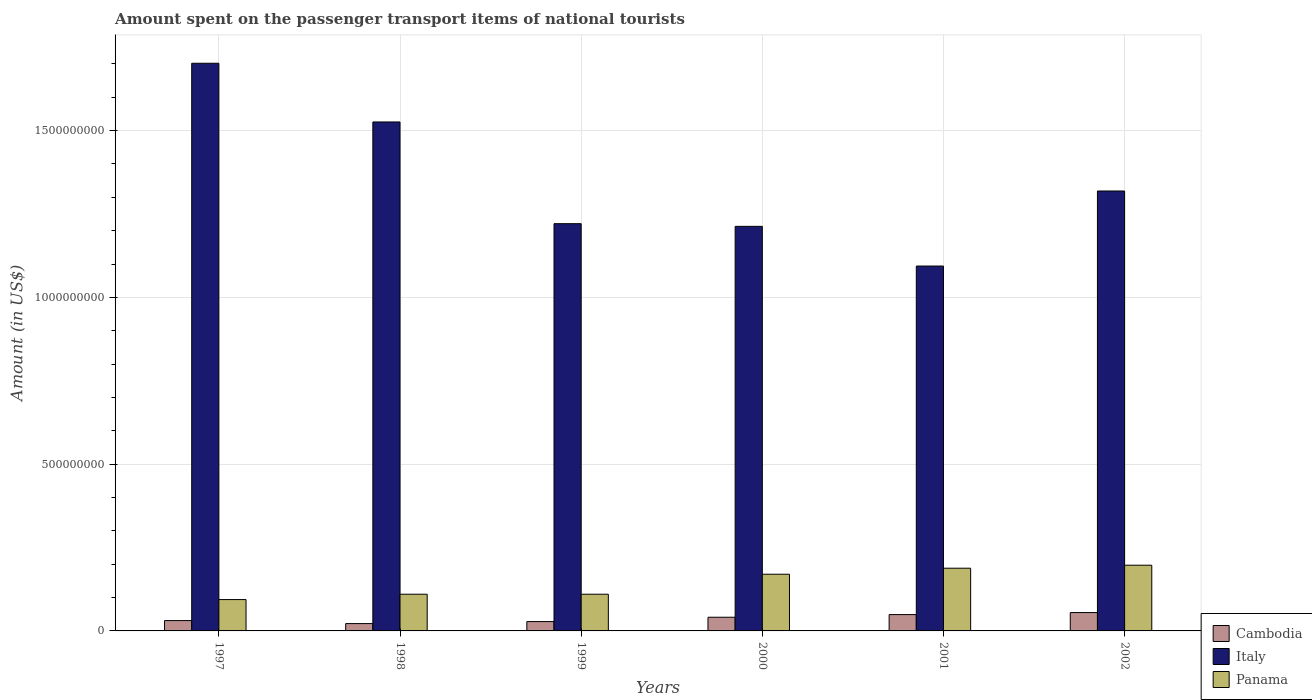How many different coloured bars are there?
Your response must be concise. 3. Are the number of bars on each tick of the X-axis equal?
Your answer should be very brief. Yes. How many bars are there on the 1st tick from the left?
Make the answer very short. 3. In how many cases, is the number of bars for a given year not equal to the number of legend labels?
Your answer should be very brief. 0. What is the amount spent on the passenger transport items of national tourists in Italy in 2002?
Keep it short and to the point. 1.32e+09. Across all years, what is the maximum amount spent on the passenger transport items of national tourists in Cambodia?
Offer a terse response. 5.50e+07. Across all years, what is the minimum amount spent on the passenger transport items of national tourists in Italy?
Make the answer very short. 1.09e+09. In which year was the amount spent on the passenger transport items of national tourists in Cambodia maximum?
Provide a short and direct response. 2002. What is the total amount spent on the passenger transport items of national tourists in Cambodia in the graph?
Ensure brevity in your answer.  2.26e+08. What is the difference between the amount spent on the passenger transport items of national tourists in Panama in 1997 and that in 2002?
Your answer should be compact. -1.03e+08. What is the difference between the amount spent on the passenger transport items of national tourists in Italy in 2002 and the amount spent on the passenger transport items of national tourists in Cambodia in 1999?
Make the answer very short. 1.29e+09. What is the average amount spent on the passenger transport items of national tourists in Cambodia per year?
Ensure brevity in your answer.  3.77e+07. In the year 1997, what is the difference between the amount spent on the passenger transport items of national tourists in Cambodia and amount spent on the passenger transport items of national tourists in Italy?
Keep it short and to the point. -1.67e+09. In how many years, is the amount spent on the passenger transport items of national tourists in Italy greater than 1300000000 US$?
Make the answer very short. 3. What is the ratio of the amount spent on the passenger transport items of national tourists in Cambodia in 1997 to that in 1999?
Your answer should be compact. 1.11. Is the amount spent on the passenger transport items of national tourists in Italy in 1997 less than that in 1998?
Your answer should be very brief. No. Is the difference between the amount spent on the passenger transport items of national tourists in Cambodia in 2000 and 2001 greater than the difference between the amount spent on the passenger transport items of national tourists in Italy in 2000 and 2001?
Make the answer very short. No. What is the difference between the highest and the second highest amount spent on the passenger transport items of national tourists in Cambodia?
Your response must be concise. 6.00e+06. What is the difference between the highest and the lowest amount spent on the passenger transport items of national tourists in Cambodia?
Provide a short and direct response. 3.30e+07. In how many years, is the amount spent on the passenger transport items of national tourists in Panama greater than the average amount spent on the passenger transport items of national tourists in Panama taken over all years?
Your answer should be compact. 3. Is the sum of the amount spent on the passenger transport items of national tourists in Panama in 1999 and 2000 greater than the maximum amount spent on the passenger transport items of national tourists in Cambodia across all years?
Provide a short and direct response. Yes. What does the 1st bar from the right in 2001 represents?
Your response must be concise. Panama. Is it the case that in every year, the sum of the amount spent on the passenger transport items of national tourists in Panama and amount spent on the passenger transport items of national tourists in Italy is greater than the amount spent on the passenger transport items of national tourists in Cambodia?
Ensure brevity in your answer.  Yes. How many bars are there?
Your response must be concise. 18. Are all the bars in the graph horizontal?
Offer a terse response. No. What is the difference between two consecutive major ticks on the Y-axis?
Your response must be concise. 5.00e+08. Where does the legend appear in the graph?
Your answer should be compact. Bottom right. What is the title of the graph?
Your answer should be very brief. Amount spent on the passenger transport items of national tourists. What is the Amount (in US$) in Cambodia in 1997?
Keep it short and to the point. 3.10e+07. What is the Amount (in US$) in Italy in 1997?
Keep it short and to the point. 1.70e+09. What is the Amount (in US$) in Panama in 1997?
Your answer should be compact. 9.40e+07. What is the Amount (in US$) of Cambodia in 1998?
Provide a short and direct response. 2.20e+07. What is the Amount (in US$) in Italy in 1998?
Make the answer very short. 1.53e+09. What is the Amount (in US$) of Panama in 1998?
Provide a succinct answer. 1.10e+08. What is the Amount (in US$) of Cambodia in 1999?
Offer a very short reply. 2.80e+07. What is the Amount (in US$) in Italy in 1999?
Offer a terse response. 1.22e+09. What is the Amount (in US$) of Panama in 1999?
Your answer should be very brief. 1.10e+08. What is the Amount (in US$) of Cambodia in 2000?
Provide a short and direct response. 4.10e+07. What is the Amount (in US$) in Italy in 2000?
Provide a succinct answer. 1.21e+09. What is the Amount (in US$) of Panama in 2000?
Provide a succinct answer. 1.70e+08. What is the Amount (in US$) of Cambodia in 2001?
Offer a terse response. 4.90e+07. What is the Amount (in US$) in Italy in 2001?
Provide a short and direct response. 1.09e+09. What is the Amount (in US$) in Panama in 2001?
Offer a very short reply. 1.88e+08. What is the Amount (in US$) of Cambodia in 2002?
Ensure brevity in your answer.  5.50e+07. What is the Amount (in US$) in Italy in 2002?
Offer a terse response. 1.32e+09. What is the Amount (in US$) in Panama in 2002?
Offer a very short reply. 1.97e+08. Across all years, what is the maximum Amount (in US$) in Cambodia?
Your answer should be compact. 5.50e+07. Across all years, what is the maximum Amount (in US$) in Italy?
Offer a terse response. 1.70e+09. Across all years, what is the maximum Amount (in US$) of Panama?
Your answer should be very brief. 1.97e+08. Across all years, what is the minimum Amount (in US$) of Cambodia?
Ensure brevity in your answer.  2.20e+07. Across all years, what is the minimum Amount (in US$) of Italy?
Ensure brevity in your answer.  1.09e+09. Across all years, what is the minimum Amount (in US$) of Panama?
Give a very brief answer. 9.40e+07. What is the total Amount (in US$) in Cambodia in the graph?
Give a very brief answer. 2.26e+08. What is the total Amount (in US$) of Italy in the graph?
Provide a short and direct response. 8.08e+09. What is the total Amount (in US$) of Panama in the graph?
Provide a short and direct response. 8.69e+08. What is the difference between the Amount (in US$) of Cambodia in 1997 and that in 1998?
Your answer should be very brief. 9.00e+06. What is the difference between the Amount (in US$) of Italy in 1997 and that in 1998?
Your response must be concise. 1.76e+08. What is the difference between the Amount (in US$) in Panama in 1997 and that in 1998?
Provide a succinct answer. -1.60e+07. What is the difference between the Amount (in US$) in Cambodia in 1997 and that in 1999?
Make the answer very short. 3.00e+06. What is the difference between the Amount (in US$) in Italy in 1997 and that in 1999?
Your answer should be very brief. 4.81e+08. What is the difference between the Amount (in US$) of Panama in 1997 and that in 1999?
Your answer should be compact. -1.60e+07. What is the difference between the Amount (in US$) in Cambodia in 1997 and that in 2000?
Ensure brevity in your answer.  -1.00e+07. What is the difference between the Amount (in US$) of Italy in 1997 and that in 2000?
Offer a terse response. 4.89e+08. What is the difference between the Amount (in US$) of Panama in 1997 and that in 2000?
Ensure brevity in your answer.  -7.60e+07. What is the difference between the Amount (in US$) of Cambodia in 1997 and that in 2001?
Your answer should be compact. -1.80e+07. What is the difference between the Amount (in US$) of Italy in 1997 and that in 2001?
Give a very brief answer. 6.08e+08. What is the difference between the Amount (in US$) of Panama in 1997 and that in 2001?
Your answer should be very brief. -9.40e+07. What is the difference between the Amount (in US$) of Cambodia in 1997 and that in 2002?
Ensure brevity in your answer.  -2.40e+07. What is the difference between the Amount (in US$) in Italy in 1997 and that in 2002?
Your response must be concise. 3.83e+08. What is the difference between the Amount (in US$) of Panama in 1997 and that in 2002?
Your answer should be very brief. -1.03e+08. What is the difference between the Amount (in US$) of Cambodia in 1998 and that in 1999?
Ensure brevity in your answer.  -6.00e+06. What is the difference between the Amount (in US$) of Italy in 1998 and that in 1999?
Your response must be concise. 3.05e+08. What is the difference between the Amount (in US$) of Cambodia in 1998 and that in 2000?
Provide a succinct answer. -1.90e+07. What is the difference between the Amount (in US$) in Italy in 1998 and that in 2000?
Your answer should be very brief. 3.13e+08. What is the difference between the Amount (in US$) of Panama in 1998 and that in 2000?
Provide a succinct answer. -6.00e+07. What is the difference between the Amount (in US$) of Cambodia in 1998 and that in 2001?
Your answer should be very brief. -2.70e+07. What is the difference between the Amount (in US$) in Italy in 1998 and that in 2001?
Ensure brevity in your answer.  4.32e+08. What is the difference between the Amount (in US$) in Panama in 1998 and that in 2001?
Your response must be concise. -7.80e+07. What is the difference between the Amount (in US$) in Cambodia in 1998 and that in 2002?
Keep it short and to the point. -3.30e+07. What is the difference between the Amount (in US$) in Italy in 1998 and that in 2002?
Your response must be concise. 2.07e+08. What is the difference between the Amount (in US$) in Panama in 1998 and that in 2002?
Your answer should be compact. -8.70e+07. What is the difference between the Amount (in US$) in Cambodia in 1999 and that in 2000?
Ensure brevity in your answer.  -1.30e+07. What is the difference between the Amount (in US$) of Italy in 1999 and that in 2000?
Provide a succinct answer. 8.00e+06. What is the difference between the Amount (in US$) in Panama in 1999 and that in 2000?
Your answer should be compact. -6.00e+07. What is the difference between the Amount (in US$) in Cambodia in 1999 and that in 2001?
Provide a short and direct response. -2.10e+07. What is the difference between the Amount (in US$) of Italy in 1999 and that in 2001?
Your response must be concise. 1.27e+08. What is the difference between the Amount (in US$) of Panama in 1999 and that in 2001?
Offer a terse response. -7.80e+07. What is the difference between the Amount (in US$) in Cambodia in 1999 and that in 2002?
Keep it short and to the point. -2.70e+07. What is the difference between the Amount (in US$) of Italy in 1999 and that in 2002?
Offer a terse response. -9.80e+07. What is the difference between the Amount (in US$) of Panama in 1999 and that in 2002?
Your response must be concise. -8.70e+07. What is the difference between the Amount (in US$) in Cambodia in 2000 and that in 2001?
Ensure brevity in your answer.  -8.00e+06. What is the difference between the Amount (in US$) of Italy in 2000 and that in 2001?
Your answer should be compact. 1.19e+08. What is the difference between the Amount (in US$) in Panama in 2000 and that in 2001?
Keep it short and to the point. -1.80e+07. What is the difference between the Amount (in US$) in Cambodia in 2000 and that in 2002?
Offer a very short reply. -1.40e+07. What is the difference between the Amount (in US$) of Italy in 2000 and that in 2002?
Give a very brief answer. -1.06e+08. What is the difference between the Amount (in US$) of Panama in 2000 and that in 2002?
Keep it short and to the point. -2.70e+07. What is the difference between the Amount (in US$) in Cambodia in 2001 and that in 2002?
Keep it short and to the point. -6.00e+06. What is the difference between the Amount (in US$) in Italy in 2001 and that in 2002?
Make the answer very short. -2.25e+08. What is the difference between the Amount (in US$) in Panama in 2001 and that in 2002?
Give a very brief answer. -9.00e+06. What is the difference between the Amount (in US$) of Cambodia in 1997 and the Amount (in US$) of Italy in 1998?
Your answer should be compact. -1.50e+09. What is the difference between the Amount (in US$) of Cambodia in 1997 and the Amount (in US$) of Panama in 1998?
Your answer should be compact. -7.90e+07. What is the difference between the Amount (in US$) in Italy in 1997 and the Amount (in US$) in Panama in 1998?
Keep it short and to the point. 1.59e+09. What is the difference between the Amount (in US$) in Cambodia in 1997 and the Amount (in US$) in Italy in 1999?
Provide a succinct answer. -1.19e+09. What is the difference between the Amount (in US$) in Cambodia in 1997 and the Amount (in US$) in Panama in 1999?
Provide a short and direct response. -7.90e+07. What is the difference between the Amount (in US$) of Italy in 1997 and the Amount (in US$) of Panama in 1999?
Keep it short and to the point. 1.59e+09. What is the difference between the Amount (in US$) of Cambodia in 1997 and the Amount (in US$) of Italy in 2000?
Your answer should be compact. -1.18e+09. What is the difference between the Amount (in US$) in Cambodia in 1997 and the Amount (in US$) in Panama in 2000?
Your answer should be very brief. -1.39e+08. What is the difference between the Amount (in US$) in Italy in 1997 and the Amount (in US$) in Panama in 2000?
Offer a terse response. 1.53e+09. What is the difference between the Amount (in US$) in Cambodia in 1997 and the Amount (in US$) in Italy in 2001?
Keep it short and to the point. -1.06e+09. What is the difference between the Amount (in US$) in Cambodia in 1997 and the Amount (in US$) in Panama in 2001?
Give a very brief answer. -1.57e+08. What is the difference between the Amount (in US$) in Italy in 1997 and the Amount (in US$) in Panama in 2001?
Provide a short and direct response. 1.51e+09. What is the difference between the Amount (in US$) in Cambodia in 1997 and the Amount (in US$) in Italy in 2002?
Provide a short and direct response. -1.29e+09. What is the difference between the Amount (in US$) in Cambodia in 1997 and the Amount (in US$) in Panama in 2002?
Provide a short and direct response. -1.66e+08. What is the difference between the Amount (in US$) of Italy in 1997 and the Amount (in US$) of Panama in 2002?
Offer a terse response. 1.50e+09. What is the difference between the Amount (in US$) in Cambodia in 1998 and the Amount (in US$) in Italy in 1999?
Make the answer very short. -1.20e+09. What is the difference between the Amount (in US$) in Cambodia in 1998 and the Amount (in US$) in Panama in 1999?
Offer a very short reply. -8.80e+07. What is the difference between the Amount (in US$) of Italy in 1998 and the Amount (in US$) of Panama in 1999?
Provide a succinct answer. 1.42e+09. What is the difference between the Amount (in US$) of Cambodia in 1998 and the Amount (in US$) of Italy in 2000?
Provide a succinct answer. -1.19e+09. What is the difference between the Amount (in US$) of Cambodia in 1998 and the Amount (in US$) of Panama in 2000?
Ensure brevity in your answer.  -1.48e+08. What is the difference between the Amount (in US$) in Italy in 1998 and the Amount (in US$) in Panama in 2000?
Your response must be concise. 1.36e+09. What is the difference between the Amount (in US$) in Cambodia in 1998 and the Amount (in US$) in Italy in 2001?
Make the answer very short. -1.07e+09. What is the difference between the Amount (in US$) in Cambodia in 1998 and the Amount (in US$) in Panama in 2001?
Keep it short and to the point. -1.66e+08. What is the difference between the Amount (in US$) of Italy in 1998 and the Amount (in US$) of Panama in 2001?
Keep it short and to the point. 1.34e+09. What is the difference between the Amount (in US$) in Cambodia in 1998 and the Amount (in US$) in Italy in 2002?
Your answer should be compact. -1.30e+09. What is the difference between the Amount (in US$) in Cambodia in 1998 and the Amount (in US$) in Panama in 2002?
Your response must be concise. -1.75e+08. What is the difference between the Amount (in US$) in Italy in 1998 and the Amount (in US$) in Panama in 2002?
Provide a succinct answer. 1.33e+09. What is the difference between the Amount (in US$) in Cambodia in 1999 and the Amount (in US$) in Italy in 2000?
Your response must be concise. -1.18e+09. What is the difference between the Amount (in US$) in Cambodia in 1999 and the Amount (in US$) in Panama in 2000?
Your response must be concise. -1.42e+08. What is the difference between the Amount (in US$) in Italy in 1999 and the Amount (in US$) in Panama in 2000?
Provide a succinct answer. 1.05e+09. What is the difference between the Amount (in US$) in Cambodia in 1999 and the Amount (in US$) in Italy in 2001?
Your answer should be compact. -1.07e+09. What is the difference between the Amount (in US$) of Cambodia in 1999 and the Amount (in US$) of Panama in 2001?
Provide a succinct answer. -1.60e+08. What is the difference between the Amount (in US$) of Italy in 1999 and the Amount (in US$) of Panama in 2001?
Your response must be concise. 1.03e+09. What is the difference between the Amount (in US$) of Cambodia in 1999 and the Amount (in US$) of Italy in 2002?
Provide a short and direct response. -1.29e+09. What is the difference between the Amount (in US$) in Cambodia in 1999 and the Amount (in US$) in Panama in 2002?
Keep it short and to the point. -1.69e+08. What is the difference between the Amount (in US$) in Italy in 1999 and the Amount (in US$) in Panama in 2002?
Offer a terse response. 1.02e+09. What is the difference between the Amount (in US$) in Cambodia in 2000 and the Amount (in US$) in Italy in 2001?
Ensure brevity in your answer.  -1.05e+09. What is the difference between the Amount (in US$) of Cambodia in 2000 and the Amount (in US$) of Panama in 2001?
Make the answer very short. -1.47e+08. What is the difference between the Amount (in US$) of Italy in 2000 and the Amount (in US$) of Panama in 2001?
Provide a short and direct response. 1.02e+09. What is the difference between the Amount (in US$) of Cambodia in 2000 and the Amount (in US$) of Italy in 2002?
Keep it short and to the point. -1.28e+09. What is the difference between the Amount (in US$) in Cambodia in 2000 and the Amount (in US$) in Panama in 2002?
Give a very brief answer. -1.56e+08. What is the difference between the Amount (in US$) in Italy in 2000 and the Amount (in US$) in Panama in 2002?
Keep it short and to the point. 1.02e+09. What is the difference between the Amount (in US$) in Cambodia in 2001 and the Amount (in US$) in Italy in 2002?
Make the answer very short. -1.27e+09. What is the difference between the Amount (in US$) in Cambodia in 2001 and the Amount (in US$) in Panama in 2002?
Your answer should be compact. -1.48e+08. What is the difference between the Amount (in US$) of Italy in 2001 and the Amount (in US$) of Panama in 2002?
Your response must be concise. 8.97e+08. What is the average Amount (in US$) in Cambodia per year?
Your answer should be very brief. 3.77e+07. What is the average Amount (in US$) of Italy per year?
Your answer should be very brief. 1.35e+09. What is the average Amount (in US$) in Panama per year?
Offer a terse response. 1.45e+08. In the year 1997, what is the difference between the Amount (in US$) in Cambodia and Amount (in US$) in Italy?
Offer a terse response. -1.67e+09. In the year 1997, what is the difference between the Amount (in US$) of Cambodia and Amount (in US$) of Panama?
Make the answer very short. -6.30e+07. In the year 1997, what is the difference between the Amount (in US$) in Italy and Amount (in US$) in Panama?
Provide a succinct answer. 1.61e+09. In the year 1998, what is the difference between the Amount (in US$) in Cambodia and Amount (in US$) in Italy?
Provide a short and direct response. -1.50e+09. In the year 1998, what is the difference between the Amount (in US$) in Cambodia and Amount (in US$) in Panama?
Offer a terse response. -8.80e+07. In the year 1998, what is the difference between the Amount (in US$) of Italy and Amount (in US$) of Panama?
Offer a very short reply. 1.42e+09. In the year 1999, what is the difference between the Amount (in US$) of Cambodia and Amount (in US$) of Italy?
Provide a short and direct response. -1.19e+09. In the year 1999, what is the difference between the Amount (in US$) in Cambodia and Amount (in US$) in Panama?
Keep it short and to the point. -8.20e+07. In the year 1999, what is the difference between the Amount (in US$) of Italy and Amount (in US$) of Panama?
Offer a very short reply. 1.11e+09. In the year 2000, what is the difference between the Amount (in US$) in Cambodia and Amount (in US$) in Italy?
Ensure brevity in your answer.  -1.17e+09. In the year 2000, what is the difference between the Amount (in US$) in Cambodia and Amount (in US$) in Panama?
Offer a terse response. -1.29e+08. In the year 2000, what is the difference between the Amount (in US$) in Italy and Amount (in US$) in Panama?
Ensure brevity in your answer.  1.04e+09. In the year 2001, what is the difference between the Amount (in US$) of Cambodia and Amount (in US$) of Italy?
Your answer should be very brief. -1.04e+09. In the year 2001, what is the difference between the Amount (in US$) in Cambodia and Amount (in US$) in Panama?
Keep it short and to the point. -1.39e+08. In the year 2001, what is the difference between the Amount (in US$) of Italy and Amount (in US$) of Panama?
Offer a terse response. 9.06e+08. In the year 2002, what is the difference between the Amount (in US$) in Cambodia and Amount (in US$) in Italy?
Your response must be concise. -1.26e+09. In the year 2002, what is the difference between the Amount (in US$) in Cambodia and Amount (in US$) in Panama?
Your answer should be very brief. -1.42e+08. In the year 2002, what is the difference between the Amount (in US$) of Italy and Amount (in US$) of Panama?
Provide a short and direct response. 1.12e+09. What is the ratio of the Amount (in US$) of Cambodia in 1997 to that in 1998?
Provide a succinct answer. 1.41. What is the ratio of the Amount (in US$) in Italy in 1997 to that in 1998?
Your answer should be very brief. 1.12. What is the ratio of the Amount (in US$) of Panama in 1997 to that in 1998?
Provide a succinct answer. 0.85. What is the ratio of the Amount (in US$) in Cambodia in 1997 to that in 1999?
Your response must be concise. 1.11. What is the ratio of the Amount (in US$) of Italy in 1997 to that in 1999?
Make the answer very short. 1.39. What is the ratio of the Amount (in US$) of Panama in 1997 to that in 1999?
Offer a very short reply. 0.85. What is the ratio of the Amount (in US$) of Cambodia in 1997 to that in 2000?
Your response must be concise. 0.76. What is the ratio of the Amount (in US$) of Italy in 1997 to that in 2000?
Provide a short and direct response. 1.4. What is the ratio of the Amount (in US$) of Panama in 1997 to that in 2000?
Provide a succinct answer. 0.55. What is the ratio of the Amount (in US$) in Cambodia in 1997 to that in 2001?
Your answer should be compact. 0.63. What is the ratio of the Amount (in US$) of Italy in 1997 to that in 2001?
Make the answer very short. 1.56. What is the ratio of the Amount (in US$) of Panama in 1997 to that in 2001?
Give a very brief answer. 0.5. What is the ratio of the Amount (in US$) in Cambodia in 1997 to that in 2002?
Give a very brief answer. 0.56. What is the ratio of the Amount (in US$) of Italy in 1997 to that in 2002?
Your answer should be very brief. 1.29. What is the ratio of the Amount (in US$) of Panama in 1997 to that in 2002?
Offer a very short reply. 0.48. What is the ratio of the Amount (in US$) in Cambodia in 1998 to that in 1999?
Ensure brevity in your answer.  0.79. What is the ratio of the Amount (in US$) in Italy in 1998 to that in 1999?
Keep it short and to the point. 1.25. What is the ratio of the Amount (in US$) of Panama in 1998 to that in 1999?
Offer a terse response. 1. What is the ratio of the Amount (in US$) of Cambodia in 1998 to that in 2000?
Your answer should be compact. 0.54. What is the ratio of the Amount (in US$) in Italy in 1998 to that in 2000?
Your response must be concise. 1.26. What is the ratio of the Amount (in US$) of Panama in 1998 to that in 2000?
Offer a terse response. 0.65. What is the ratio of the Amount (in US$) of Cambodia in 1998 to that in 2001?
Offer a very short reply. 0.45. What is the ratio of the Amount (in US$) in Italy in 1998 to that in 2001?
Offer a very short reply. 1.39. What is the ratio of the Amount (in US$) in Panama in 1998 to that in 2001?
Offer a very short reply. 0.59. What is the ratio of the Amount (in US$) of Cambodia in 1998 to that in 2002?
Offer a very short reply. 0.4. What is the ratio of the Amount (in US$) of Italy in 1998 to that in 2002?
Offer a very short reply. 1.16. What is the ratio of the Amount (in US$) in Panama in 1998 to that in 2002?
Offer a very short reply. 0.56. What is the ratio of the Amount (in US$) of Cambodia in 1999 to that in 2000?
Your response must be concise. 0.68. What is the ratio of the Amount (in US$) in Italy in 1999 to that in 2000?
Keep it short and to the point. 1.01. What is the ratio of the Amount (in US$) of Panama in 1999 to that in 2000?
Give a very brief answer. 0.65. What is the ratio of the Amount (in US$) in Cambodia in 1999 to that in 2001?
Make the answer very short. 0.57. What is the ratio of the Amount (in US$) of Italy in 1999 to that in 2001?
Offer a terse response. 1.12. What is the ratio of the Amount (in US$) of Panama in 1999 to that in 2001?
Ensure brevity in your answer.  0.59. What is the ratio of the Amount (in US$) of Cambodia in 1999 to that in 2002?
Offer a terse response. 0.51. What is the ratio of the Amount (in US$) in Italy in 1999 to that in 2002?
Provide a short and direct response. 0.93. What is the ratio of the Amount (in US$) of Panama in 1999 to that in 2002?
Make the answer very short. 0.56. What is the ratio of the Amount (in US$) in Cambodia in 2000 to that in 2001?
Provide a succinct answer. 0.84. What is the ratio of the Amount (in US$) in Italy in 2000 to that in 2001?
Your answer should be very brief. 1.11. What is the ratio of the Amount (in US$) of Panama in 2000 to that in 2001?
Give a very brief answer. 0.9. What is the ratio of the Amount (in US$) of Cambodia in 2000 to that in 2002?
Offer a terse response. 0.75. What is the ratio of the Amount (in US$) of Italy in 2000 to that in 2002?
Provide a succinct answer. 0.92. What is the ratio of the Amount (in US$) in Panama in 2000 to that in 2002?
Offer a terse response. 0.86. What is the ratio of the Amount (in US$) in Cambodia in 2001 to that in 2002?
Give a very brief answer. 0.89. What is the ratio of the Amount (in US$) of Italy in 2001 to that in 2002?
Provide a succinct answer. 0.83. What is the ratio of the Amount (in US$) in Panama in 2001 to that in 2002?
Offer a terse response. 0.95. What is the difference between the highest and the second highest Amount (in US$) of Cambodia?
Your response must be concise. 6.00e+06. What is the difference between the highest and the second highest Amount (in US$) of Italy?
Keep it short and to the point. 1.76e+08. What is the difference between the highest and the second highest Amount (in US$) in Panama?
Ensure brevity in your answer.  9.00e+06. What is the difference between the highest and the lowest Amount (in US$) in Cambodia?
Make the answer very short. 3.30e+07. What is the difference between the highest and the lowest Amount (in US$) of Italy?
Keep it short and to the point. 6.08e+08. What is the difference between the highest and the lowest Amount (in US$) in Panama?
Your response must be concise. 1.03e+08. 